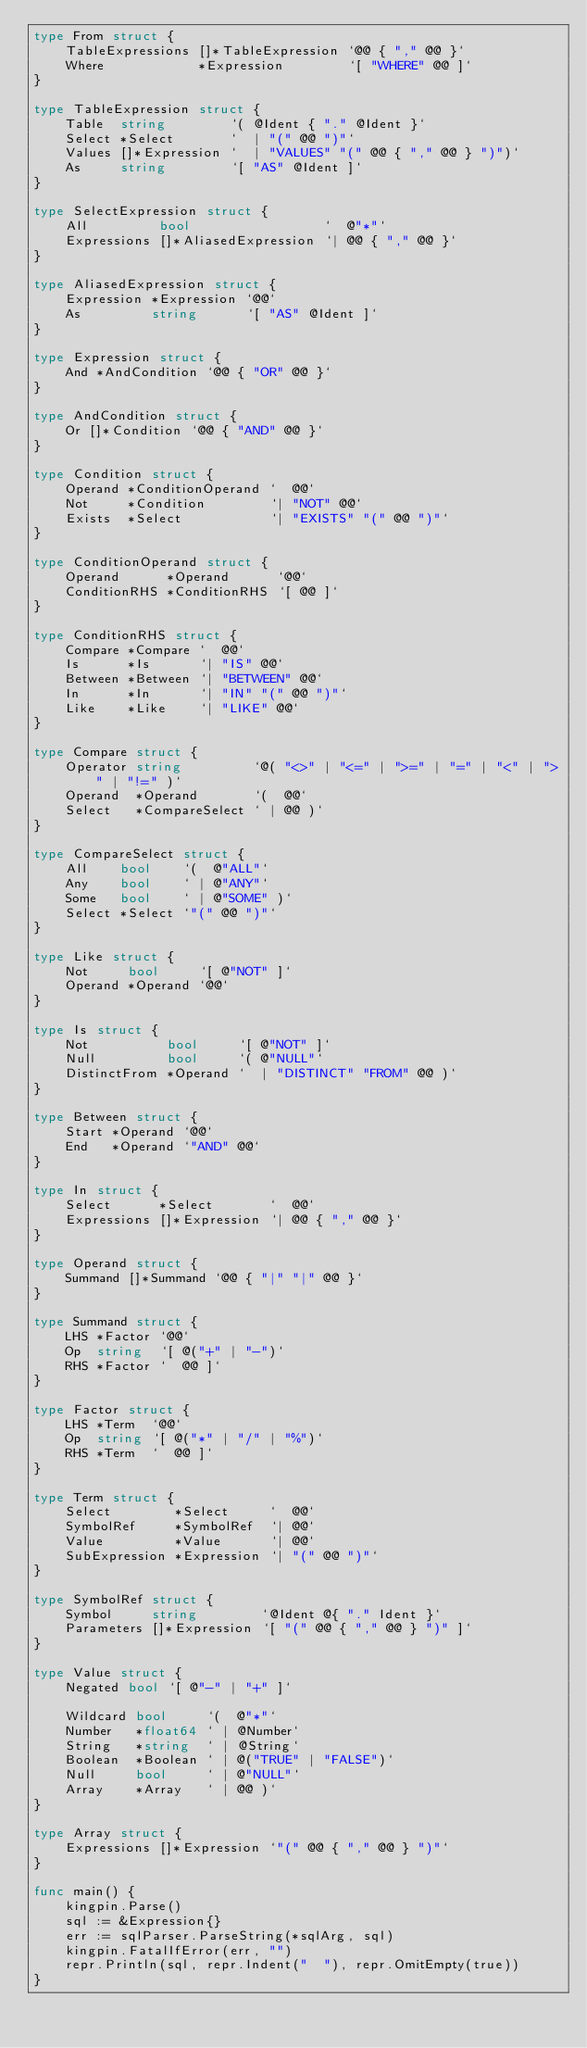Convert code to text. <code><loc_0><loc_0><loc_500><loc_500><_Go_>type From struct {
	TableExpressions []*TableExpression `@@ { "," @@ }`
	Where            *Expression        `[ "WHERE" @@ ]`
}

type TableExpression struct {
	Table  string        `( @Ident { "." @Ident }`
	Select *Select       `  | "(" @@ ")"`
	Values []*Expression `  | "VALUES" "(" @@ { "," @@ } ")")`
	As     string        `[ "AS" @Ident ]`
}

type SelectExpression struct {
	All         bool                 `  @"*"`
	Expressions []*AliasedExpression `| @@ { "," @@ }`
}

type AliasedExpression struct {
	Expression *Expression `@@`
	As         string      `[ "AS" @Ident ]`
}

type Expression struct {
	And *AndCondition `@@ { "OR" @@ }`
}

type AndCondition struct {
	Or []*Condition `@@ { "AND" @@ }`
}

type Condition struct {
	Operand *ConditionOperand `  @@`
	Not     *Condition        `| "NOT" @@`
	Exists  *Select           `| "EXISTS" "(" @@ ")"`
}

type ConditionOperand struct {
	Operand      *Operand      `@@`
	ConditionRHS *ConditionRHS `[ @@ ]`
}

type ConditionRHS struct {
	Compare *Compare `  @@`
	Is      *Is      `| "IS" @@`
	Between *Between `| "BETWEEN" @@`
	In      *In      `| "IN" "(" @@ ")"`
	Like    *Like    `| "LIKE" @@`
}

type Compare struct {
	Operator string         `@( "<>" | "<=" | ">=" | "=" | "<" | ">" | "!=" )`
	Operand  *Operand       `(  @@`
	Select   *CompareSelect ` | @@ )`
}

type CompareSelect struct {
	All    bool    `(  @"ALL"`
	Any    bool    ` | @"ANY"`
	Some   bool    ` | @"SOME" )`
	Select *Select `"(" @@ ")"`
}

type Like struct {
	Not     bool     `[ @"NOT" ]`
	Operand *Operand `@@`
}

type Is struct {
	Not          bool     `[ @"NOT" ]`
	Null         bool     `( @"NULL"`
	DistinctFrom *Operand `  | "DISTINCT" "FROM" @@ )`
}

type Between struct {
	Start *Operand `@@`
	End   *Operand `"AND" @@`
}

type In struct {
	Select      *Select       `  @@`
	Expressions []*Expression `| @@ { "," @@ }`
}

type Operand struct {
	Summand []*Summand `@@ { "|" "|" @@ }`
}

type Summand struct {
	LHS *Factor `@@`
	Op  string  `[ @("+" | "-")`
	RHS *Factor `  @@ ]`
}

type Factor struct {
	LHS *Term  `@@`
	Op  string `[ @("*" | "/" | "%")`
	RHS *Term  `  @@ ]`
}

type Term struct {
	Select        *Select     `  @@`
	SymbolRef     *SymbolRef  `| @@`
	Value         *Value      `| @@`
	SubExpression *Expression `| "(" @@ ")"`
}

type SymbolRef struct {
	Symbol     string        `@Ident @{ "." Ident }`
	Parameters []*Expression `[ "(" @@ { "," @@ } ")" ]`
}

type Value struct {
	Negated bool `[ @"-" | "+" ]`

	Wildcard bool     `(  @"*"`
	Number   *float64 ` | @Number`
	String   *string  ` | @String`
	Boolean  *Boolean ` | @("TRUE" | "FALSE")`
	Null     bool     ` | @"NULL"`
	Array    *Array   ` | @@ )`
}

type Array struct {
	Expressions []*Expression `"(" @@ { "," @@ } ")"`
}

func main() {
	kingpin.Parse()
	sql := &Expression{}
	err := sqlParser.ParseString(*sqlArg, sql)
	kingpin.FatalIfError(err, "")
	repr.Println(sql, repr.Indent("  "), repr.OmitEmpty(true))
}
</code> 